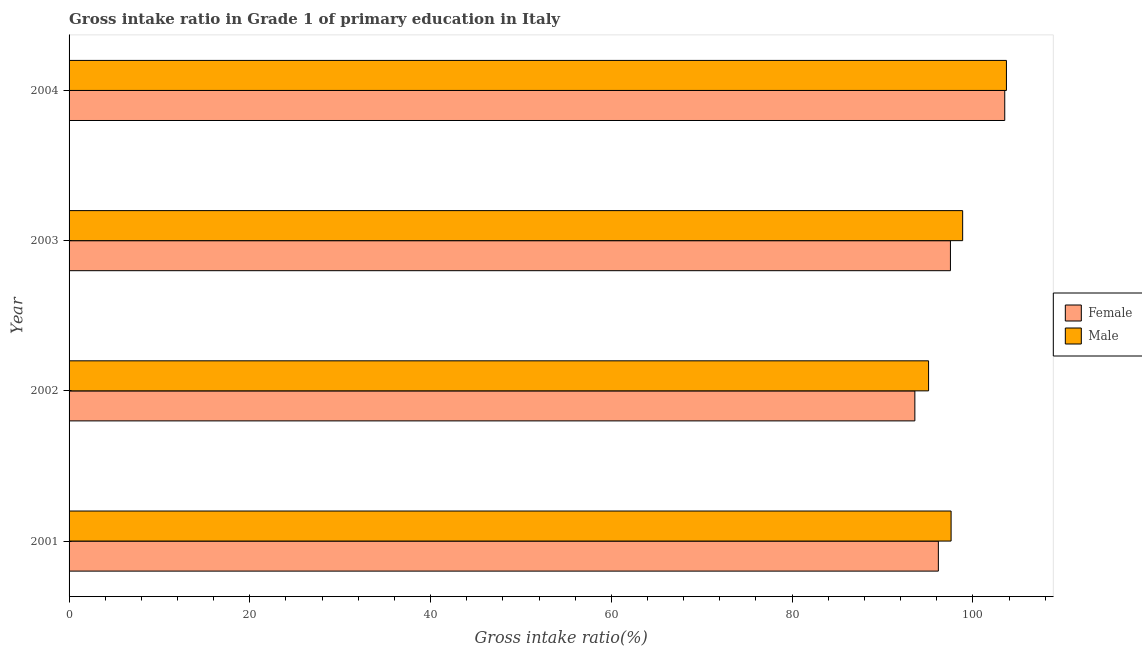How many groups of bars are there?
Your answer should be compact. 4. What is the gross intake ratio(female) in 2003?
Your answer should be compact. 97.52. Across all years, what is the maximum gross intake ratio(female)?
Your response must be concise. 103.53. Across all years, what is the minimum gross intake ratio(male)?
Keep it short and to the point. 95.1. In which year was the gross intake ratio(female) minimum?
Provide a short and direct response. 2002. What is the total gross intake ratio(female) in the graph?
Your answer should be compact. 390.81. What is the difference between the gross intake ratio(female) in 2002 and that in 2004?
Provide a short and direct response. -9.95. What is the difference between the gross intake ratio(male) in 2003 and the gross intake ratio(female) in 2001?
Give a very brief answer. 2.69. What is the average gross intake ratio(male) per year?
Make the answer very short. 98.82. In the year 2002, what is the difference between the gross intake ratio(female) and gross intake ratio(male)?
Make the answer very short. -1.52. In how many years, is the gross intake ratio(female) greater than 88 %?
Your answer should be compact. 4. What is the ratio of the gross intake ratio(female) in 2002 to that in 2004?
Ensure brevity in your answer.  0.9. Is the gross intake ratio(male) in 2001 less than that in 2002?
Ensure brevity in your answer.  No. Is the difference between the gross intake ratio(female) in 2001 and 2004 greater than the difference between the gross intake ratio(male) in 2001 and 2004?
Give a very brief answer. No. What is the difference between the highest and the second highest gross intake ratio(male)?
Your answer should be compact. 4.84. What is the difference between the highest and the lowest gross intake ratio(male)?
Make the answer very short. 8.62. In how many years, is the gross intake ratio(female) greater than the average gross intake ratio(female) taken over all years?
Make the answer very short. 1. Is the sum of the gross intake ratio(female) in 2003 and 2004 greater than the maximum gross intake ratio(male) across all years?
Give a very brief answer. Yes. How many bars are there?
Ensure brevity in your answer.  8. Are all the bars in the graph horizontal?
Give a very brief answer. Yes. How many years are there in the graph?
Your answer should be compact. 4. Does the graph contain any zero values?
Ensure brevity in your answer.  No. Does the graph contain grids?
Your answer should be very brief. No. How many legend labels are there?
Your response must be concise. 2. What is the title of the graph?
Ensure brevity in your answer.  Gross intake ratio in Grade 1 of primary education in Italy. Does "US$" appear as one of the legend labels in the graph?
Provide a short and direct response. No. What is the label or title of the X-axis?
Provide a succinct answer. Gross intake ratio(%). What is the label or title of the Y-axis?
Provide a succinct answer. Year. What is the Gross intake ratio(%) in Female in 2001?
Ensure brevity in your answer.  96.18. What is the Gross intake ratio(%) in Male in 2001?
Offer a very short reply. 97.59. What is the Gross intake ratio(%) of Female in 2002?
Offer a terse response. 93.58. What is the Gross intake ratio(%) of Male in 2002?
Make the answer very short. 95.1. What is the Gross intake ratio(%) of Female in 2003?
Keep it short and to the point. 97.52. What is the Gross intake ratio(%) of Male in 2003?
Offer a terse response. 98.87. What is the Gross intake ratio(%) of Female in 2004?
Provide a short and direct response. 103.53. What is the Gross intake ratio(%) of Male in 2004?
Ensure brevity in your answer.  103.72. Across all years, what is the maximum Gross intake ratio(%) of Female?
Your answer should be compact. 103.53. Across all years, what is the maximum Gross intake ratio(%) in Male?
Provide a short and direct response. 103.72. Across all years, what is the minimum Gross intake ratio(%) in Female?
Make the answer very short. 93.58. Across all years, what is the minimum Gross intake ratio(%) of Male?
Provide a short and direct response. 95.1. What is the total Gross intake ratio(%) of Female in the graph?
Give a very brief answer. 390.81. What is the total Gross intake ratio(%) of Male in the graph?
Your response must be concise. 395.28. What is the difference between the Gross intake ratio(%) of Female in 2001 and that in 2002?
Offer a very short reply. 2.6. What is the difference between the Gross intake ratio(%) of Male in 2001 and that in 2002?
Keep it short and to the point. 2.49. What is the difference between the Gross intake ratio(%) of Female in 2001 and that in 2003?
Provide a short and direct response. -1.34. What is the difference between the Gross intake ratio(%) of Male in 2001 and that in 2003?
Your answer should be very brief. -1.28. What is the difference between the Gross intake ratio(%) of Female in 2001 and that in 2004?
Keep it short and to the point. -7.35. What is the difference between the Gross intake ratio(%) in Male in 2001 and that in 2004?
Provide a short and direct response. -6.12. What is the difference between the Gross intake ratio(%) in Female in 2002 and that in 2003?
Make the answer very short. -3.94. What is the difference between the Gross intake ratio(%) of Male in 2002 and that in 2003?
Your response must be concise. -3.77. What is the difference between the Gross intake ratio(%) in Female in 2002 and that in 2004?
Ensure brevity in your answer.  -9.95. What is the difference between the Gross intake ratio(%) in Male in 2002 and that in 2004?
Ensure brevity in your answer.  -8.62. What is the difference between the Gross intake ratio(%) in Female in 2003 and that in 2004?
Your answer should be very brief. -6.01. What is the difference between the Gross intake ratio(%) of Male in 2003 and that in 2004?
Provide a short and direct response. -4.84. What is the difference between the Gross intake ratio(%) in Female in 2001 and the Gross intake ratio(%) in Male in 2002?
Give a very brief answer. 1.08. What is the difference between the Gross intake ratio(%) of Female in 2001 and the Gross intake ratio(%) of Male in 2003?
Provide a short and direct response. -2.69. What is the difference between the Gross intake ratio(%) in Female in 2001 and the Gross intake ratio(%) in Male in 2004?
Provide a short and direct response. -7.53. What is the difference between the Gross intake ratio(%) of Female in 2002 and the Gross intake ratio(%) of Male in 2003?
Offer a very short reply. -5.29. What is the difference between the Gross intake ratio(%) of Female in 2002 and the Gross intake ratio(%) of Male in 2004?
Give a very brief answer. -10.13. What is the difference between the Gross intake ratio(%) in Female in 2003 and the Gross intake ratio(%) in Male in 2004?
Make the answer very short. -6.2. What is the average Gross intake ratio(%) of Female per year?
Your answer should be very brief. 97.7. What is the average Gross intake ratio(%) of Male per year?
Offer a very short reply. 98.82. In the year 2001, what is the difference between the Gross intake ratio(%) of Female and Gross intake ratio(%) of Male?
Give a very brief answer. -1.41. In the year 2002, what is the difference between the Gross intake ratio(%) in Female and Gross intake ratio(%) in Male?
Give a very brief answer. -1.52. In the year 2003, what is the difference between the Gross intake ratio(%) in Female and Gross intake ratio(%) in Male?
Offer a terse response. -1.35. In the year 2004, what is the difference between the Gross intake ratio(%) of Female and Gross intake ratio(%) of Male?
Your answer should be compact. -0.19. What is the ratio of the Gross intake ratio(%) in Female in 2001 to that in 2002?
Offer a terse response. 1.03. What is the ratio of the Gross intake ratio(%) in Male in 2001 to that in 2002?
Provide a short and direct response. 1.03. What is the ratio of the Gross intake ratio(%) in Female in 2001 to that in 2003?
Your answer should be very brief. 0.99. What is the ratio of the Gross intake ratio(%) of Male in 2001 to that in 2003?
Your response must be concise. 0.99. What is the ratio of the Gross intake ratio(%) in Female in 2001 to that in 2004?
Keep it short and to the point. 0.93. What is the ratio of the Gross intake ratio(%) of Male in 2001 to that in 2004?
Ensure brevity in your answer.  0.94. What is the ratio of the Gross intake ratio(%) in Female in 2002 to that in 2003?
Ensure brevity in your answer.  0.96. What is the ratio of the Gross intake ratio(%) in Male in 2002 to that in 2003?
Keep it short and to the point. 0.96. What is the ratio of the Gross intake ratio(%) in Female in 2002 to that in 2004?
Your answer should be very brief. 0.9. What is the ratio of the Gross intake ratio(%) in Male in 2002 to that in 2004?
Give a very brief answer. 0.92. What is the ratio of the Gross intake ratio(%) in Female in 2003 to that in 2004?
Offer a very short reply. 0.94. What is the ratio of the Gross intake ratio(%) in Male in 2003 to that in 2004?
Offer a very short reply. 0.95. What is the difference between the highest and the second highest Gross intake ratio(%) in Female?
Your answer should be very brief. 6.01. What is the difference between the highest and the second highest Gross intake ratio(%) in Male?
Provide a short and direct response. 4.84. What is the difference between the highest and the lowest Gross intake ratio(%) of Female?
Provide a short and direct response. 9.95. What is the difference between the highest and the lowest Gross intake ratio(%) in Male?
Your answer should be compact. 8.62. 